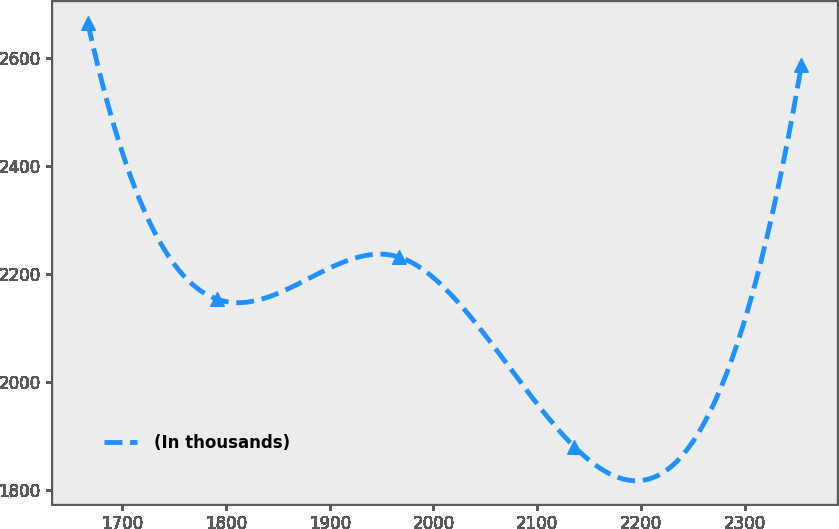Convert chart to OTSL. <chart><loc_0><loc_0><loc_500><loc_500><line_chart><ecel><fcel>(In thousands)<nl><fcel>1666.72<fcel>2663.4<nl><fcel>1790.98<fcel>2153.85<nl><fcel>1967.05<fcel>2231.42<nl><fcel>2135.87<fcel>1880.7<nl><fcel>2354.86<fcel>2585.83<nl></chart> 